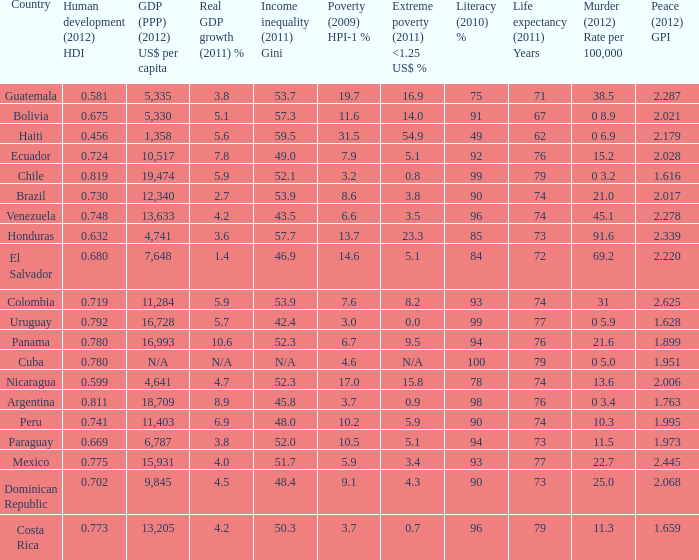What murder (2012) rate per 100,00 also has a 1.616 as the peace (2012) GPI? 0 3.2. Can you parse all the data within this table? {'header': ['Country', 'Human development (2012) HDI', 'GDP (PPP) (2012) US$ per capita', 'Real GDP growth (2011) %', 'Income inequality (2011) Gini', 'Poverty (2009) HPI-1 %', 'Extreme poverty (2011) <1.25 US$ %', 'Literacy (2010) %', 'Life expectancy (2011) Years', 'Murder (2012) Rate per 100,000', 'Peace (2012) GPI'], 'rows': [['Guatemala', '0.581', '5,335', '3.8', '53.7', '19.7', '16.9', '75', '71', '38.5', '2.287'], ['Bolivia', '0.675', '5,330', '5.1', '57.3', '11.6', '14.0', '91', '67', '0 8.9', '2.021'], ['Haiti', '0.456', '1,358', '5.6', '59.5', '31.5', '54.9', '49', '62', '0 6.9', '2.179'], ['Ecuador', '0.724', '10,517', '7.8', '49.0', '7.9', '5.1', '92', '76', '15.2', '2.028'], ['Chile', '0.819', '19,474', '5.9', '52.1', '3.2', '0.8', '99', '79', '0 3.2', '1.616'], ['Brazil', '0.730', '12,340', '2.7', '53.9', '8.6', '3.8', '90', '74', '21.0', '2.017'], ['Venezuela', '0.748', '13,633', '4.2', '43.5', '6.6', '3.5', '96', '74', '45.1', '2.278'], ['Honduras', '0.632', '4,741', '3.6', '57.7', '13.7', '23.3', '85', '73', '91.6', '2.339'], ['El Salvador', '0.680', '7,648', '1.4', '46.9', '14.6', '5.1', '84', '72', '69.2', '2.220'], ['Colombia', '0.719', '11,284', '5.9', '53.9', '7.6', '8.2', '93', '74', '31', '2.625'], ['Uruguay', '0.792', '16,728', '5.7', '42.4', '3.0', '0.0', '99', '77', '0 5.9', '1.628'], ['Panama', '0.780', '16,993', '10.6', '52.3', '6.7', '9.5', '94', '76', '21.6', '1.899'], ['Cuba', '0.780', 'N/A', 'N/A', 'N/A', '4.6', 'N/A', '100', '79', '0 5.0', '1.951'], ['Nicaragua', '0.599', '4,641', '4.7', '52.3', '17.0', '15.8', '78', '74', '13.6', '2.006'], ['Argentina', '0.811', '18,709', '8.9', '45.8', '3.7', '0.9', '98', '76', '0 3.4', '1.763'], ['Peru', '0.741', '11,403', '6.9', '48.0', '10.2', '5.9', '90', '74', '10.3', '1.995'], ['Paraguay', '0.669', '6,787', '3.8', '52.0', '10.5', '5.1', '94', '73', '11.5', '1.973'], ['Mexico', '0.775', '15,931', '4.0', '51.7', '5.9', '3.4', '93', '77', '22.7', '2.445'], ['Dominican Republic', '0.702', '9,845', '4.5', '48.4', '9.1', '4.3', '90', '73', '25.0', '2.068'], ['Costa Rica', '0.773', '13,205', '4.2', '50.3', '3.7', '0.7', '96', '79', '11.3', '1.659']]} 